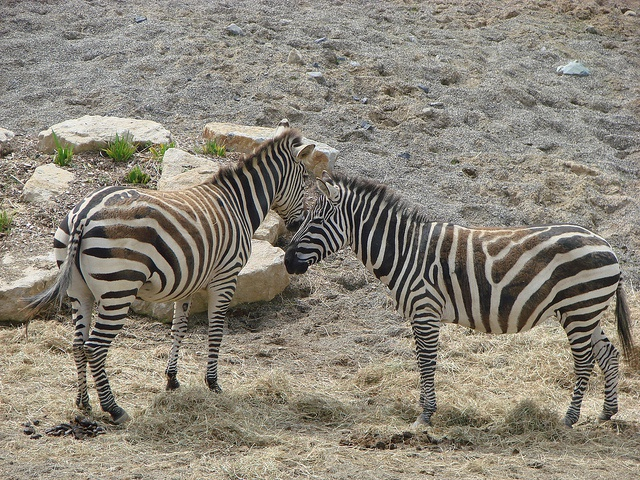Describe the objects in this image and their specific colors. I can see zebra in gray, black, and darkgray tones and zebra in gray, black, and darkgray tones in this image. 